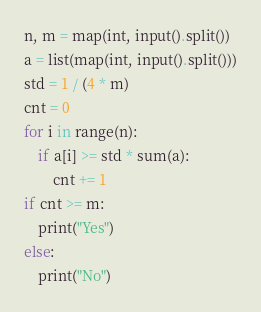Convert code to text. <code><loc_0><loc_0><loc_500><loc_500><_Python_>n, m = map(int, input().split())
a = list(map(int, input().split()))
std = 1 / (4 * m)
cnt = 0
for i in range(n):
    if a[i] >= std * sum(a):
        cnt += 1
if cnt >= m:
    print("Yes")
else:
    print("No")</code> 